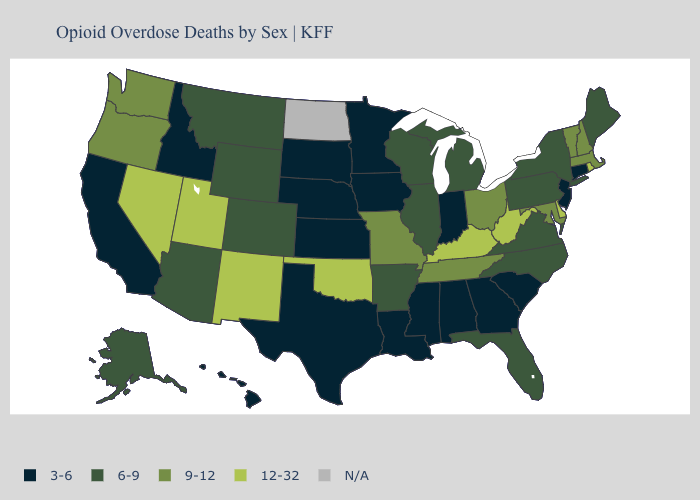What is the highest value in the USA?
Write a very short answer. 12-32. What is the value of Texas?
Quick response, please. 3-6. Which states have the highest value in the USA?
Give a very brief answer. Delaware, Kentucky, Nevada, New Mexico, Oklahoma, Rhode Island, Utah, West Virginia. Which states hav the highest value in the Northeast?
Answer briefly. Rhode Island. Name the states that have a value in the range 6-9?
Give a very brief answer. Alaska, Arizona, Arkansas, Colorado, Florida, Illinois, Maine, Michigan, Montana, New York, North Carolina, Pennsylvania, Virginia, Wisconsin, Wyoming. Does North Carolina have the lowest value in the USA?
Quick response, please. No. What is the value of North Carolina?
Quick response, please. 6-9. Name the states that have a value in the range 9-12?
Write a very short answer. Maryland, Massachusetts, Missouri, New Hampshire, Ohio, Oregon, Tennessee, Vermont, Washington. Name the states that have a value in the range 6-9?
Quick response, please. Alaska, Arizona, Arkansas, Colorado, Florida, Illinois, Maine, Michigan, Montana, New York, North Carolina, Pennsylvania, Virginia, Wisconsin, Wyoming. Name the states that have a value in the range 9-12?
Quick response, please. Maryland, Massachusetts, Missouri, New Hampshire, Ohio, Oregon, Tennessee, Vermont, Washington. Name the states that have a value in the range 12-32?
Answer briefly. Delaware, Kentucky, Nevada, New Mexico, Oklahoma, Rhode Island, Utah, West Virginia. Does Kentucky have the highest value in the USA?
Concise answer only. Yes. Does New Jersey have the lowest value in the Northeast?
Answer briefly. Yes. Name the states that have a value in the range 3-6?
Answer briefly. Alabama, California, Connecticut, Georgia, Hawaii, Idaho, Indiana, Iowa, Kansas, Louisiana, Minnesota, Mississippi, Nebraska, New Jersey, South Carolina, South Dakota, Texas. 